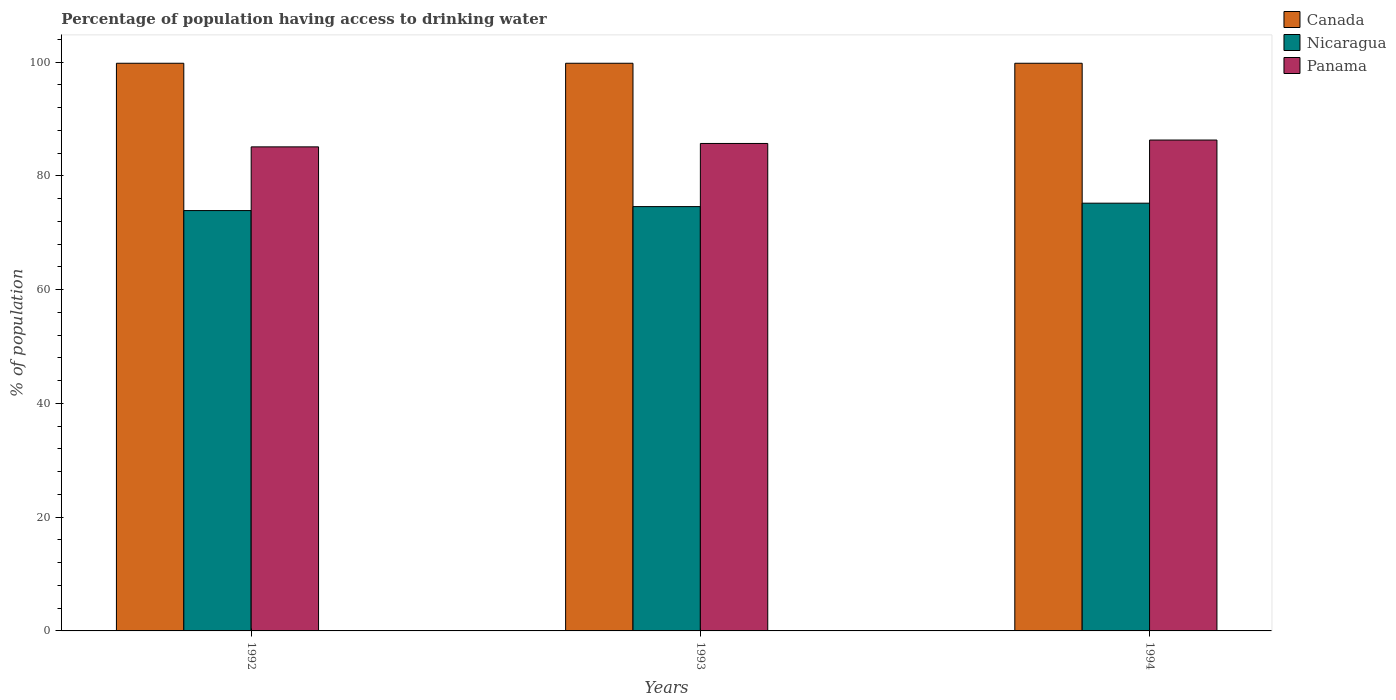How many groups of bars are there?
Provide a succinct answer. 3. Are the number of bars per tick equal to the number of legend labels?
Give a very brief answer. Yes. Are the number of bars on each tick of the X-axis equal?
Provide a succinct answer. Yes. How many bars are there on the 3rd tick from the left?
Keep it short and to the point. 3. In how many cases, is the number of bars for a given year not equal to the number of legend labels?
Your answer should be very brief. 0. What is the percentage of population having access to drinking water in Panama in 1992?
Your answer should be compact. 85.1. Across all years, what is the maximum percentage of population having access to drinking water in Canada?
Offer a very short reply. 99.8. Across all years, what is the minimum percentage of population having access to drinking water in Panama?
Keep it short and to the point. 85.1. What is the total percentage of population having access to drinking water in Canada in the graph?
Ensure brevity in your answer.  299.4. What is the difference between the percentage of population having access to drinking water in Nicaragua in 1993 and that in 1994?
Give a very brief answer. -0.6. What is the difference between the percentage of population having access to drinking water in Panama in 1993 and the percentage of population having access to drinking water in Nicaragua in 1994?
Give a very brief answer. 10.5. What is the average percentage of population having access to drinking water in Panama per year?
Your response must be concise. 85.7. In the year 1993, what is the difference between the percentage of population having access to drinking water in Nicaragua and percentage of population having access to drinking water in Canada?
Offer a very short reply. -25.2. In how many years, is the percentage of population having access to drinking water in Nicaragua greater than 12 %?
Offer a terse response. 3. What is the ratio of the percentage of population having access to drinking water in Nicaragua in 1993 to that in 1994?
Offer a terse response. 0.99. Is the percentage of population having access to drinking water in Panama in 1992 less than that in 1993?
Your answer should be compact. Yes. Is the difference between the percentage of population having access to drinking water in Nicaragua in 1992 and 1994 greater than the difference between the percentage of population having access to drinking water in Canada in 1992 and 1994?
Make the answer very short. No. What is the difference between the highest and the second highest percentage of population having access to drinking water in Canada?
Keep it short and to the point. 0. What is the difference between the highest and the lowest percentage of population having access to drinking water in Nicaragua?
Provide a succinct answer. 1.3. Is the sum of the percentage of population having access to drinking water in Panama in 1993 and 1994 greater than the maximum percentage of population having access to drinking water in Canada across all years?
Offer a terse response. Yes. What does the 2nd bar from the right in 1992 represents?
Provide a succinct answer. Nicaragua. How many bars are there?
Keep it short and to the point. 9. How many years are there in the graph?
Your answer should be compact. 3. What is the difference between two consecutive major ticks on the Y-axis?
Provide a succinct answer. 20. Are the values on the major ticks of Y-axis written in scientific E-notation?
Offer a terse response. No. Does the graph contain any zero values?
Give a very brief answer. No. Where does the legend appear in the graph?
Your answer should be compact. Top right. How many legend labels are there?
Keep it short and to the point. 3. How are the legend labels stacked?
Your answer should be compact. Vertical. What is the title of the graph?
Ensure brevity in your answer.  Percentage of population having access to drinking water. Does "Botswana" appear as one of the legend labels in the graph?
Your answer should be compact. No. What is the label or title of the Y-axis?
Your answer should be very brief. % of population. What is the % of population in Canada in 1992?
Your answer should be very brief. 99.8. What is the % of population of Nicaragua in 1992?
Provide a succinct answer. 73.9. What is the % of population in Panama in 1992?
Your answer should be very brief. 85.1. What is the % of population of Canada in 1993?
Your response must be concise. 99.8. What is the % of population in Nicaragua in 1993?
Provide a short and direct response. 74.6. What is the % of population of Panama in 1993?
Keep it short and to the point. 85.7. What is the % of population in Canada in 1994?
Provide a succinct answer. 99.8. What is the % of population in Nicaragua in 1994?
Give a very brief answer. 75.2. What is the % of population of Panama in 1994?
Ensure brevity in your answer.  86.3. Across all years, what is the maximum % of population in Canada?
Ensure brevity in your answer.  99.8. Across all years, what is the maximum % of population of Nicaragua?
Give a very brief answer. 75.2. Across all years, what is the maximum % of population in Panama?
Your answer should be very brief. 86.3. Across all years, what is the minimum % of population in Canada?
Ensure brevity in your answer.  99.8. Across all years, what is the minimum % of population of Nicaragua?
Offer a very short reply. 73.9. Across all years, what is the minimum % of population in Panama?
Your response must be concise. 85.1. What is the total % of population in Canada in the graph?
Your answer should be compact. 299.4. What is the total % of population in Nicaragua in the graph?
Make the answer very short. 223.7. What is the total % of population in Panama in the graph?
Offer a terse response. 257.1. What is the difference between the % of population in Panama in 1992 and that in 1993?
Your answer should be very brief. -0.6. What is the difference between the % of population in Canada in 1992 and that in 1994?
Your answer should be very brief. 0. What is the difference between the % of population of Nicaragua in 1992 and that in 1994?
Your answer should be very brief. -1.3. What is the difference between the % of population of Panama in 1992 and that in 1994?
Offer a terse response. -1.2. What is the difference between the % of population in Nicaragua in 1993 and that in 1994?
Your answer should be very brief. -0.6. What is the difference between the % of population in Panama in 1993 and that in 1994?
Make the answer very short. -0.6. What is the difference between the % of population of Canada in 1992 and the % of population of Nicaragua in 1993?
Offer a terse response. 25.2. What is the difference between the % of population of Canada in 1992 and the % of population of Nicaragua in 1994?
Your answer should be compact. 24.6. What is the difference between the % of population of Canada in 1992 and the % of population of Panama in 1994?
Offer a very short reply. 13.5. What is the difference between the % of population of Canada in 1993 and the % of population of Nicaragua in 1994?
Keep it short and to the point. 24.6. What is the average % of population in Canada per year?
Your answer should be very brief. 99.8. What is the average % of population in Nicaragua per year?
Keep it short and to the point. 74.57. What is the average % of population of Panama per year?
Make the answer very short. 85.7. In the year 1992, what is the difference between the % of population in Canada and % of population in Nicaragua?
Offer a terse response. 25.9. In the year 1992, what is the difference between the % of population in Canada and % of population in Panama?
Keep it short and to the point. 14.7. In the year 1993, what is the difference between the % of population of Canada and % of population of Nicaragua?
Ensure brevity in your answer.  25.2. In the year 1993, what is the difference between the % of population of Nicaragua and % of population of Panama?
Provide a succinct answer. -11.1. In the year 1994, what is the difference between the % of population in Canada and % of population in Nicaragua?
Offer a terse response. 24.6. In the year 1994, what is the difference between the % of population in Canada and % of population in Panama?
Offer a very short reply. 13.5. What is the ratio of the % of population of Canada in 1992 to that in 1993?
Provide a short and direct response. 1. What is the ratio of the % of population in Nicaragua in 1992 to that in 1993?
Your answer should be very brief. 0.99. What is the ratio of the % of population in Panama in 1992 to that in 1993?
Your response must be concise. 0.99. What is the ratio of the % of population in Nicaragua in 1992 to that in 1994?
Provide a short and direct response. 0.98. What is the ratio of the % of population of Panama in 1992 to that in 1994?
Your answer should be very brief. 0.99. What is the ratio of the % of population of Canada in 1993 to that in 1994?
Give a very brief answer. 1. What is the ratio of the % of population in Panama in 1993 to that in 1994?
Offer a terse response. 0.99. What is the difference between the highest and the second highest % of population in Panama?
Your answer should be compact. 0.6. What is the difference between the highest and the lowest % of population of Canada?
Your response must be concise. 0. What is the difference between the highest and the lowest % of population in Nicaragua?
Offer a terse response. 1.3. What is the difference between the highest and the lowest % of population of Panama?
Give a very brief answer. 1.2. 